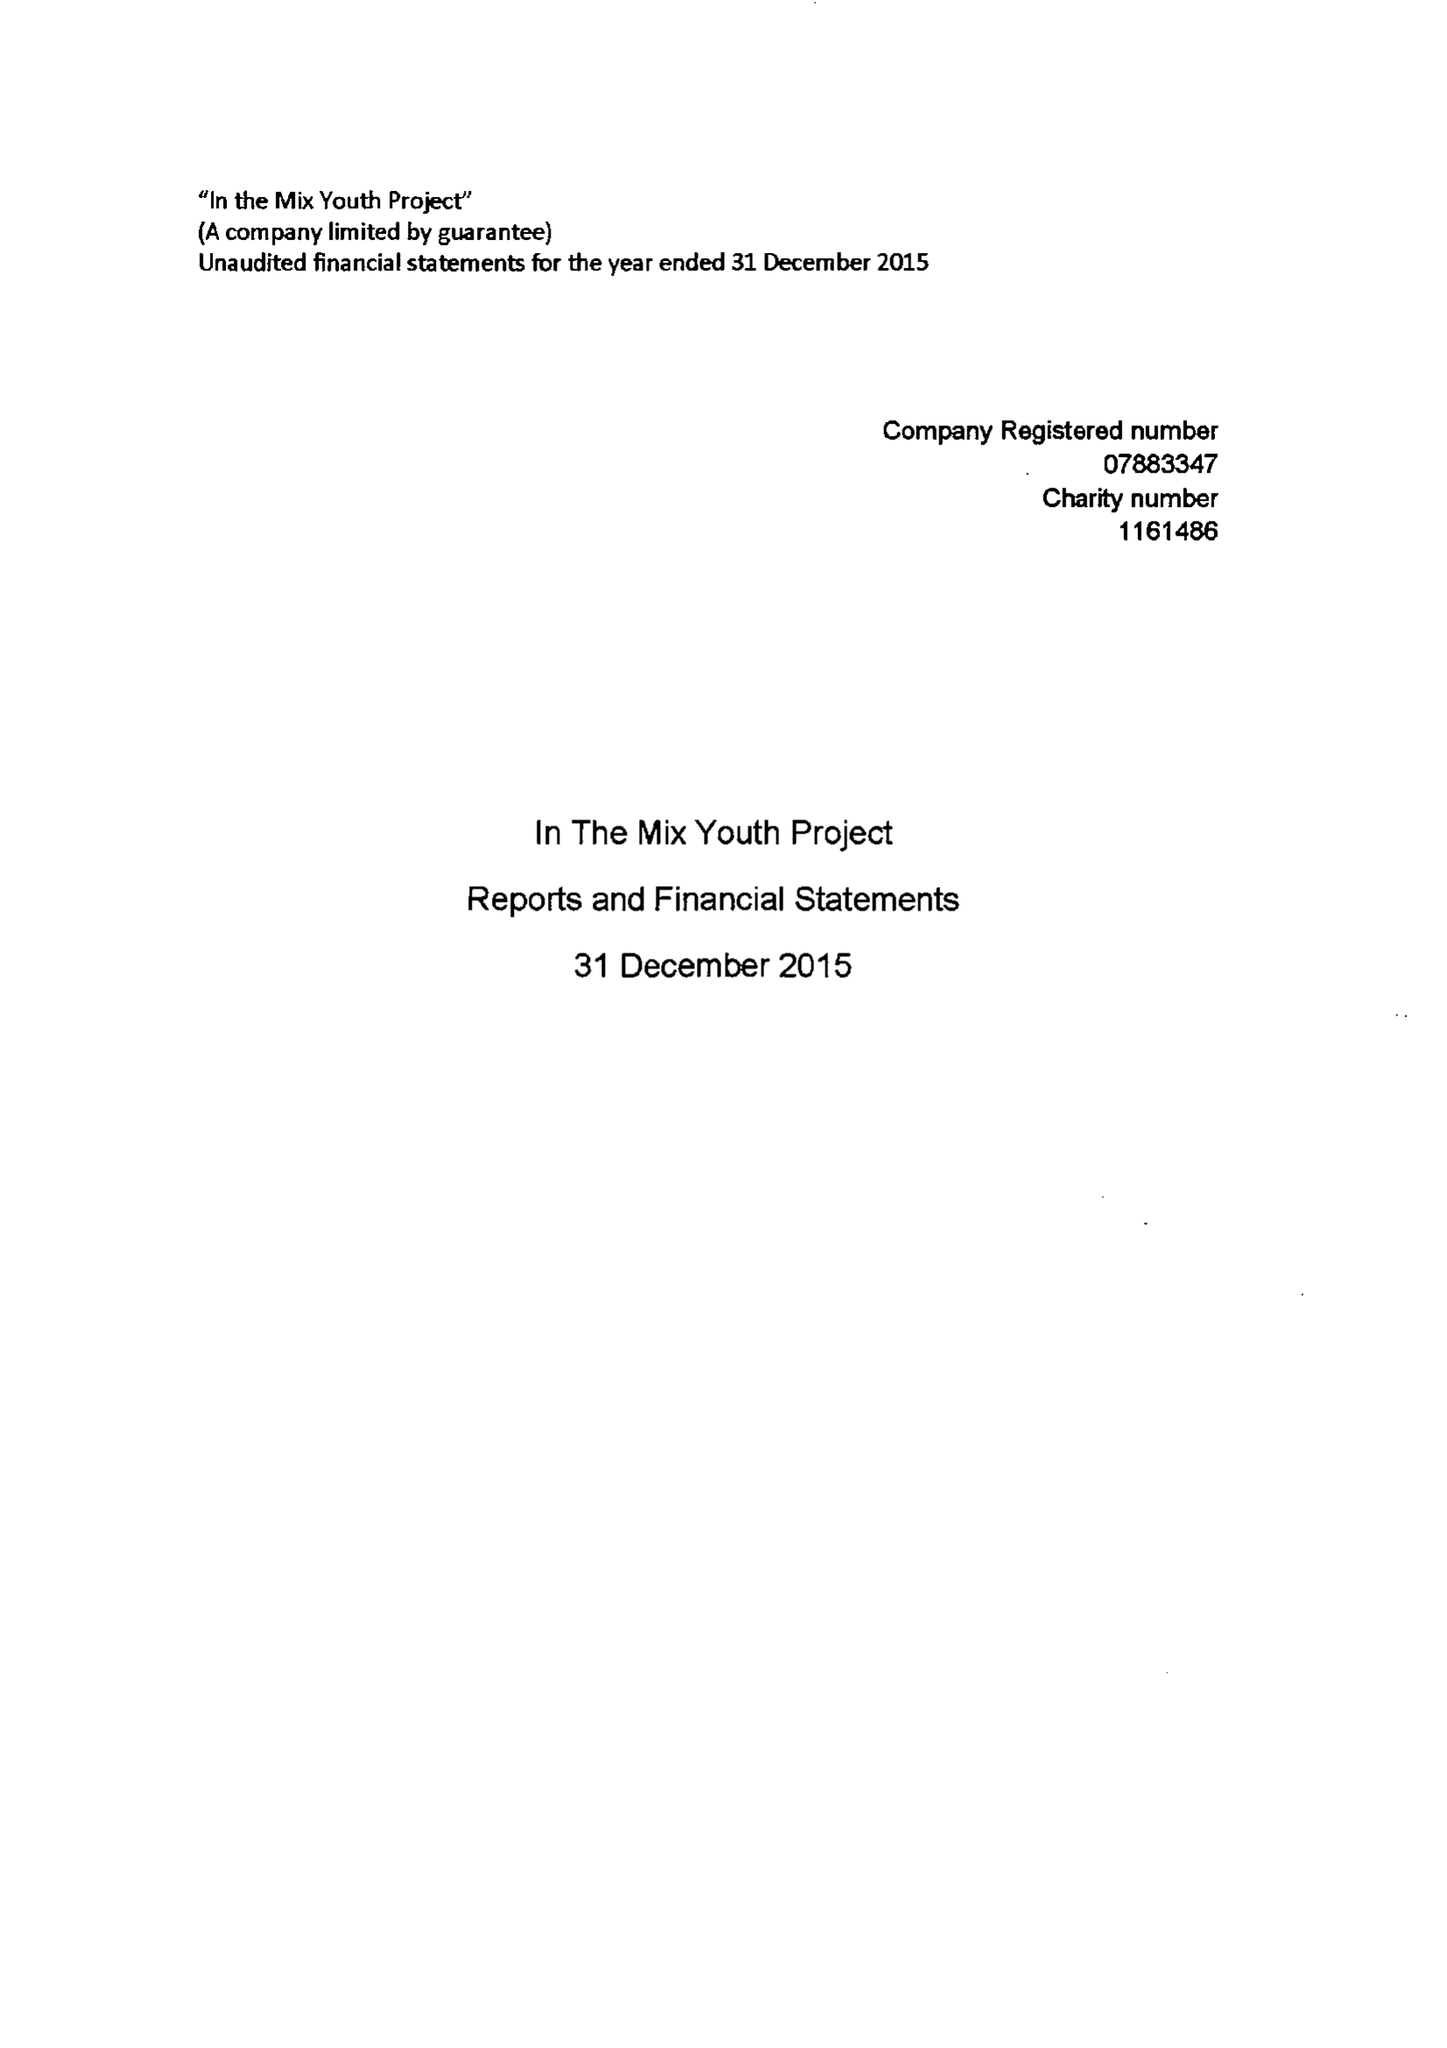What is the value for the address__post_town?
Answer the question using a single word or phrase. TAUNTON 